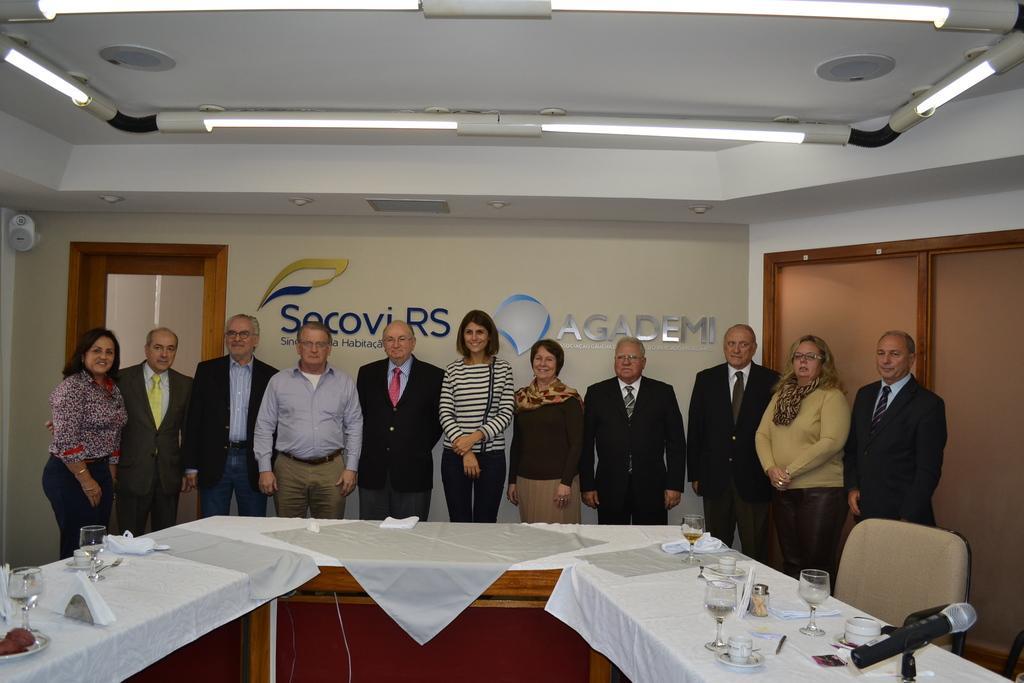How would you summarize this image in a sentence or two? This image consists of so many people. There are tables in this room and there is a cloth placed on the table. There is a chair. There are plates eatables glasses tissues on this table. There are lights on the top. 